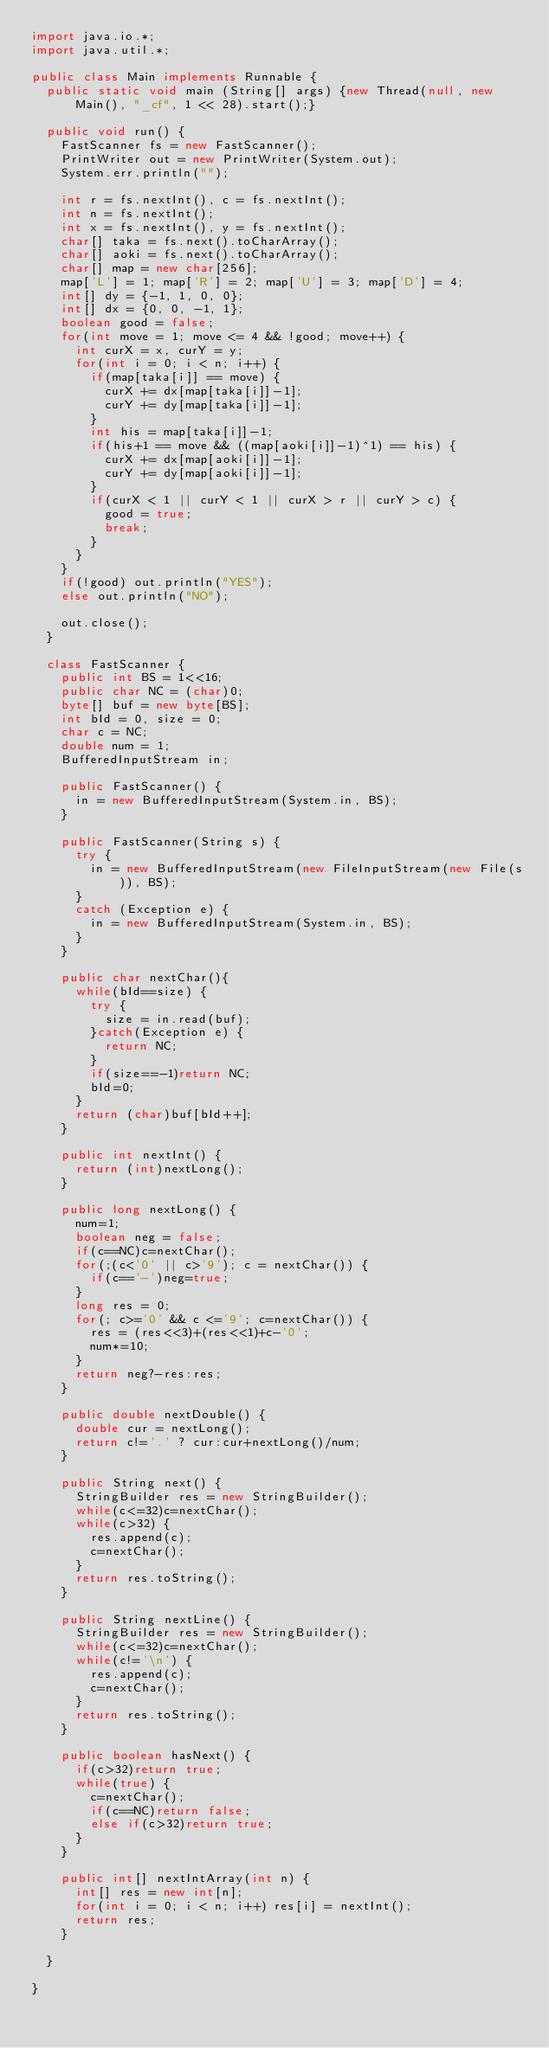Convert code to text. <code><loc_0><loc_0><loc_500><loc_500><_Java_>import java.io.*;
import java.util.*;

public class Main implements Runnable {
	public static void main (String[] args) {new Thread(null, new Main(), "_cf", 1 << 28).start();}

	public void run() {
		FastScanner fs = new FastScanner();
		PrintWriter out = new PrintWriter(System.out);
		System.err.println("");

		int r = fs.nextInt(), c = fs.nextInt();
		int n = fs.nextInt();
		int x = fs.nextInt(), y = fs.nextInt();
		char[] taka = fs.next().toCharArray();
		char[] aoki = fs.next().toCharArray();
		char[] map = new char[256];
		map['L'] = 1; map['R'] = 2; map['U'] = 3; map['D'] = 4;
		int[] dy = {-1, 1, 0, 0};
		int[] dx = {0, 0, -1, 1};
		boolean good = false;
		for(int move = 1; move <= 4 && !good; move++) {
			int curX = x, curY = y;
			for(int i = 0; i < n; i++) {
				if(map[taka[i]] == move) {
					curX += dx[map[taka[i]]-1];
					curY += dy[map[taka[i]]-1];
				}
				int his = map[taka[i]]-1;
				if(his+1 == move && ((map[aoki[i]]-1)^1) == his) {
					curX += dx[map[aoki[i]]-1];
					curY += dy[map[aoki[i]]-1];
				}
				if(curX < 1 || curY < 1 || curX > r || curY > c) {
					good = true;
					break;
				}
			}
		}
		if(!good) out.println("YES");
		else out.println("NO");
		
		out.close();
	}

	class FastScanner {
		public int BS = 1<<16;
		public char NC = (char)0;
		byte[] buf = new byte[BS];
		int bId = 0, size = 0;
		char c = NC;
		double num = 1;
		BufferedInputStream in;

		public FastScanner() {
			in = new BufferedInputStream(System.in, BS);
		}

		public FastScanner(String s) {
			try {
				in = new BufferedInputStream(new FileInputStream(new File(s)), BS);
			}
			catch (Exception e) {
				in = new BufferedInputStream(System.in, BS);
			}
		}

		public char nextChar(){
			while(bId==size) {
				try {
					size = in.read(buf);
				}catch(Exception e) {
					return NC;
				}                
				if(size==-1)return NC;
				bId=0;
			}
			return (char)buf[bId++];
		}

		public int nextInt() {
			return (int)nextLong();
		}

		public long nextLong() {
			num=1;
			boolean neg = false;
			if(c==NC)c=nextChar();
			for(;(c<'0' || c>'9'); c = nextChar()) {
				if(c=='-')neg=true;
			}
			long res = 0;
			for(; c>='0' && c <='9'; c=nextChar()) {
				res = (res<<3)+(res<<1)+c-'0';
				num*=10;
			}
			return neg?-res:res;
		}

		public double nextDouble() {
			double cur = nextLong();
			return c!='.' ? cur:cur+nextLong()/num;
		}

		public String next() {
			StringBuilder res = new StringBuilder();
			while(c<=32)c=nextChar();
			while(c>32) {
				res.append(c);
				c=nextChar();
			}
			return res.toString();
		}

		public String nextLine() {
			StringBuilder res = new StringBuilder();
			while(c<=32)c=nextChar();
			while(c!='\n') {
				res.append(c);
				c=nextChar();
			}
			return res.toString();
		}

		public boolean hasNext() {
			if(c>32)return true;
			while(true) {
				c=nextChar();
				if(c==NC)return false;
				else if(c>32)return true;
			}
		}
		
		public int[] nextIntArray(int n) {
			int[] res = new int[n];
			for(int i = 0; i < n; i++) res[i] = nextInt();
			return res;
		}
		
	}

}</code> 